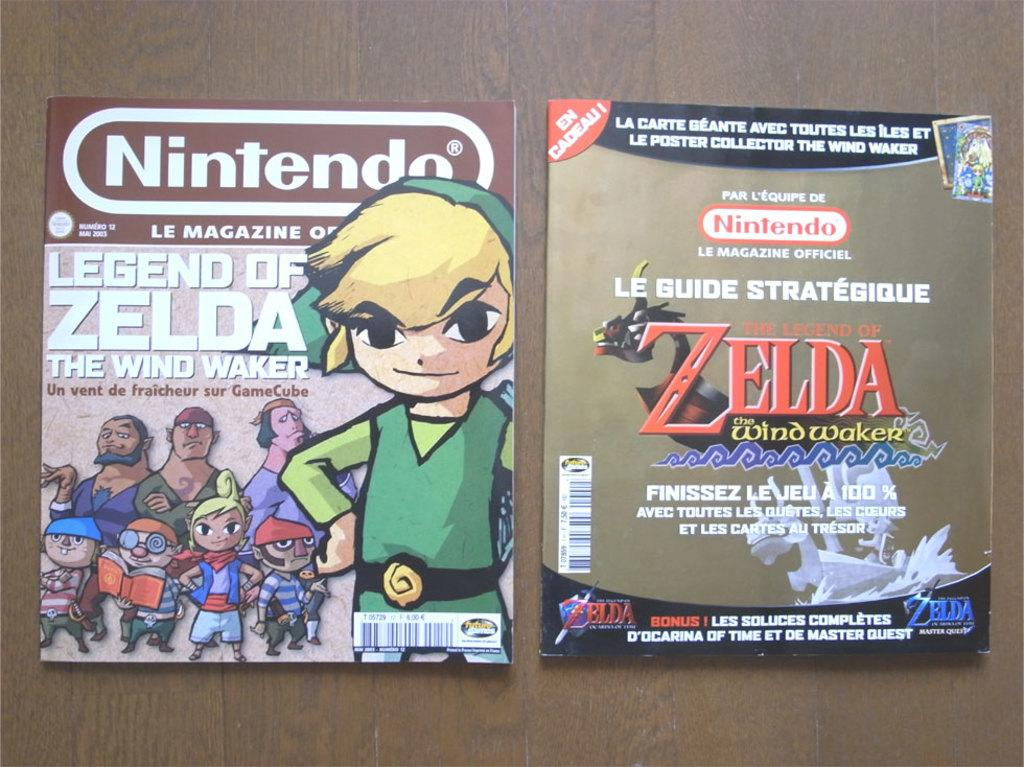What objects are on the table in the image? There are two books on the table. What can be seen on the books? There is text visible on the books. Can you describe the people in the image? There are persons in the image, but their specific characteristics are not mentioned in the provided facts. What type of ice can be seen melting on the books in the image? There is no ice present on the books in the image. What color is the pen used to write on the books in the image? There is no pen visible on the books in the image. 